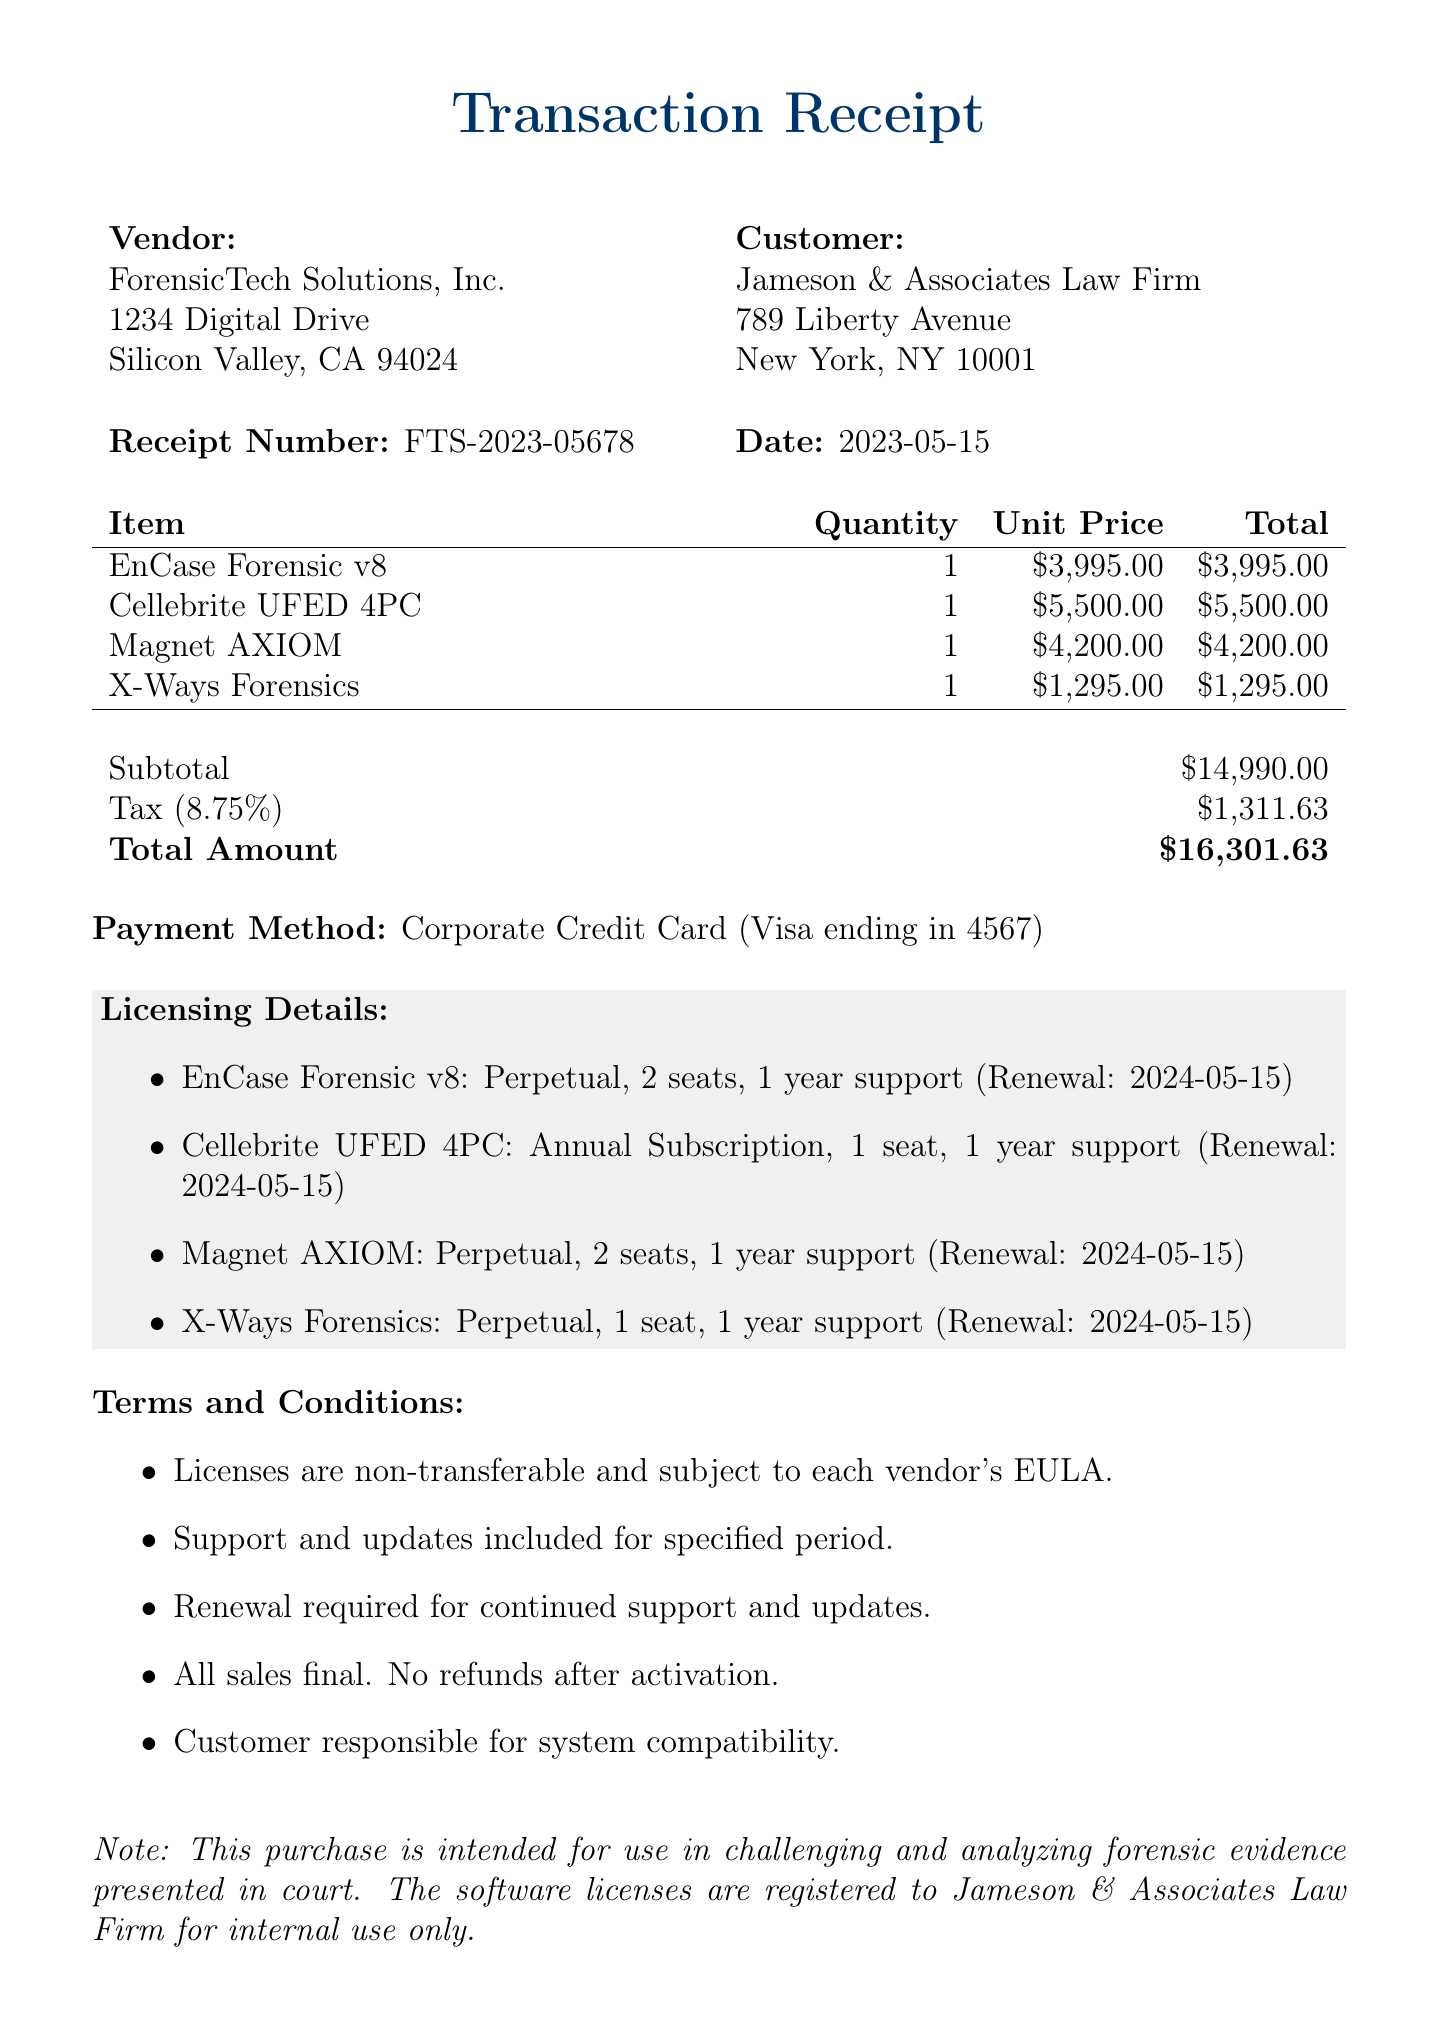What is the vendor's name? The vendor's name is listed at the beginning of the document under the vendor section.
Answer: ForensicTech Solutions, Inc What is the total amount charged? The total amount charged is calculated as the sum of the subtotal and tax amount detailed in the document.
Answer: $16,301.63 What software has a unit price of $5,500.00? The unit prices for each item are listed in the itemized section, specifically looking for the one with this price.
Answer: Cellebrite UFED 4PC How many seats are included for Magnet AXIOM? The licensing details specify the number of seats for each software in the list of licensing information.
Answer: 2 seats What is the tax rate applied? The tax rate is explicitly mentioned in the financial summary section of the document.
Answer: 8.75% What type of license is associated with X-Ways Forensics? The license type for each item is listed in the licensing details section; it can be identified by looking at X-Ways Forensics.
Answer: Perpetual What is the renewal date for all software licenses? The renewal date for each software is consistently listed in the licensing details section.
Answer: 2024-05-15 What is the receipt number? The receipt number is stated clearly in the document under the receipt details.
Answer: FTS-2023-05678 What payment method was used for this transaction? The payment details are provided toward the end of the document and specify the method of payment.
Answer: Corporate Credit Card 